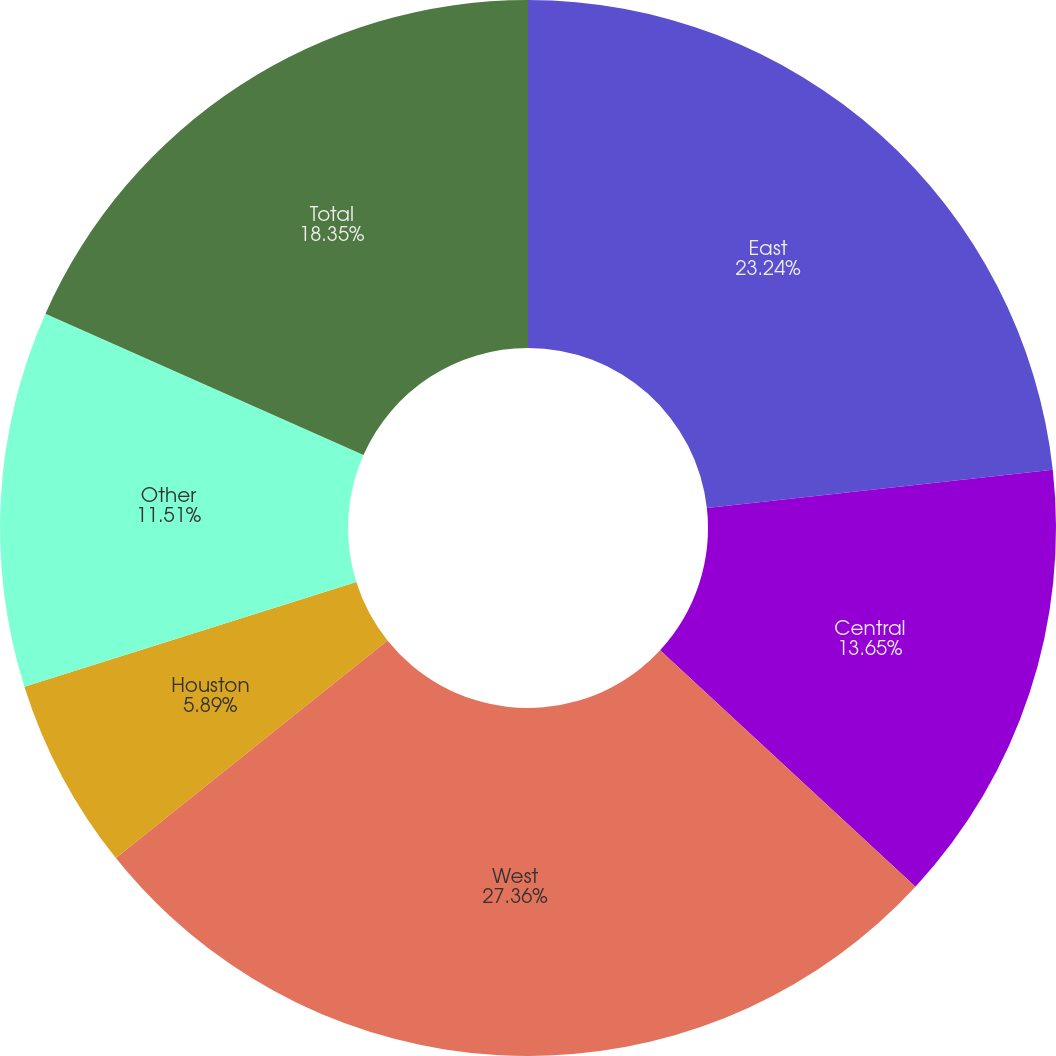Convert chart to OTSL. <chart><loc_0><loc_0><loc_500><loc_500><pie_chart><fcel>East<fcel>Central<fcel>West<fcel>Houston<fcel>Other<fcel>Total<nl><fcel>23.24%<fcel>13.65%<fcel>27.37%<fcel>5.89%<fcel>11.51%<fcel>18.35%<nl></chart> 